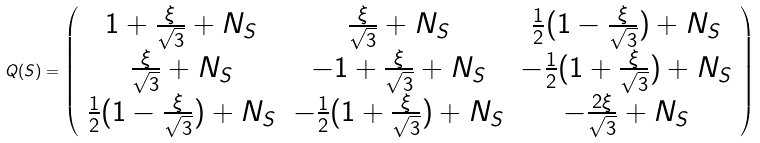Convert formula to latex. <formula><loc_0><loc_0><loc_500><loc_500>Q ( S ) = \left ( \begin{array} { c c c } { { 1 + \frac { \xi } { \sqrt { 3 } } + N _ { S } } } & { { \frac { \xi } { \sqrt { 3 } } + N _ { S } } } & { { \frac { 1 } { 2 } ( 1 - \frac { \xi } { \sqrt { 3 } } ) + N _ { S } } } \\ { { \frac { \xi } { \sqrt { 3 } } + N _ { S } } } & { { - 1 + \frac { \xi } { \sqrt { 3 } } + N _ { S } } } & { { - \frac { 1 } { 2 } ( 1 + \frac { \xi } { \sqrt { 3 } } ) + N _ { S } } } \\ { { \frac { 1 } { 2 } ( 1 - \frac { \xi } { \sqrt { 3 } } ) + N _ { S } } } & { { - \frac { 1 } { 2 } ( 1 + \frac { \xi } { \sqrt { 3 } } ) + N _ { S } } } & { { - \frac { 2 \xi } { \sqrt { 3 } } + N _ { S } } } \end{array} \right )</formula> 